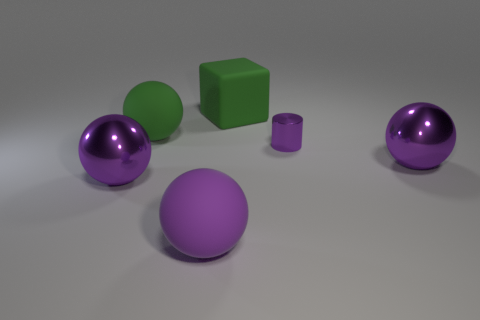Subtract all purple balls. How many were subtracted if there are1purple balls left? 2 Subtract all cyan blocks. How many purple balls are left? 3 Subtract 2 spheres. How many spheres are left? 2 Add 1 large purple metal objects. How many objects exist? 7 Subtract all cyan balls. Subtract all gray cubes. How many balls are left? 4 Subtract all balls. How many objects are left? 2 Subtract 0 gray cubes. How many objects are left? 6 Subtract all metallic objects. Subtract all large blocks. How many objects are left? 2 Add 1 large purple spheres. How many large purple spheres are left? 4 Add 6 purple metal balls. How many purple metal balls exist? 8 